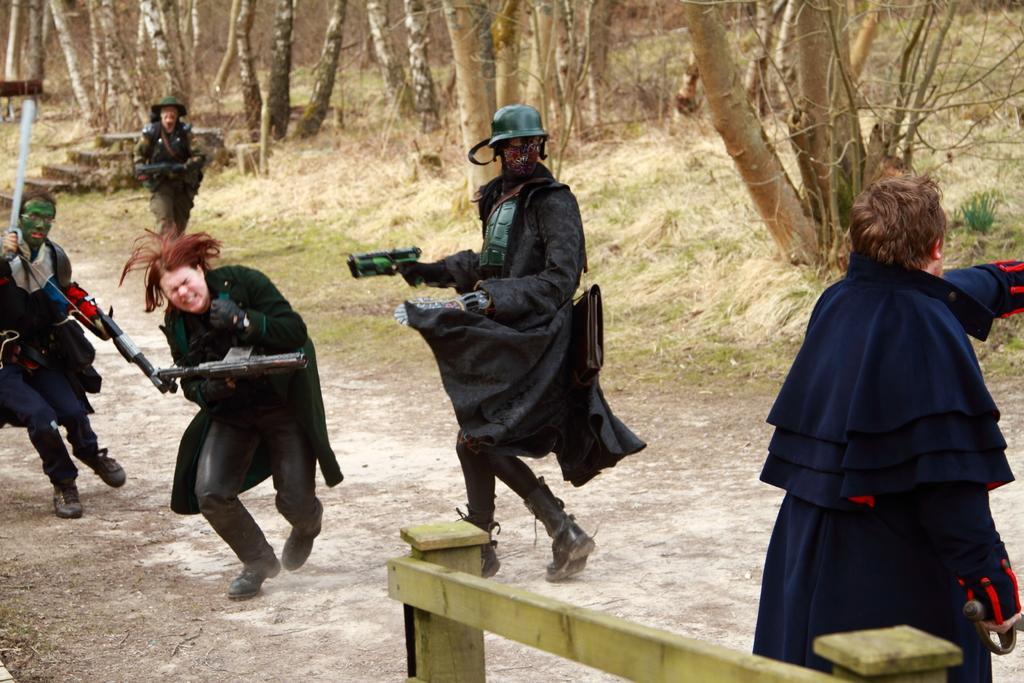Can you describe this image briefly? In this picture I can see there are few people and the person on to right is wearing a blue dress and holding a sword and there is a person next to him and he is holding a gun and wearing a mask. There is another person next to him holding a gun and there is another person at left he is wearing a green mask and holding a mask and there is another person running in the backdrop and there is grass and there are trees in the backdrop. 